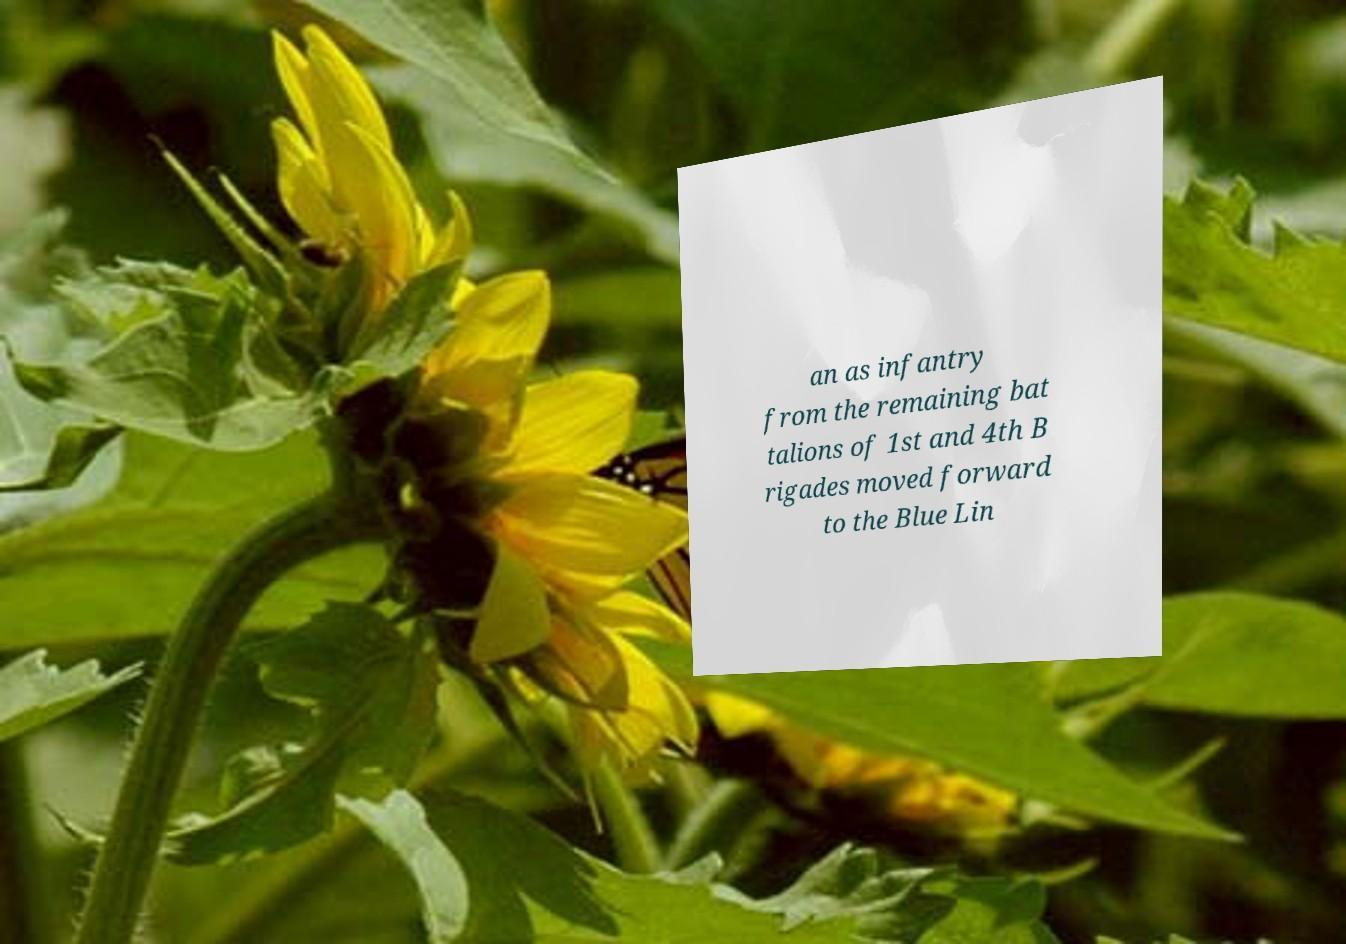Could you extract and type out the text from this image? an as infantry from the remaining bat talions of 1st and 4th B rigades moved forward to the Blue Lin 